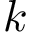Convert formula to latex. <formula><loc_0><loc_0><loc_500><loc_500>k</formula> 